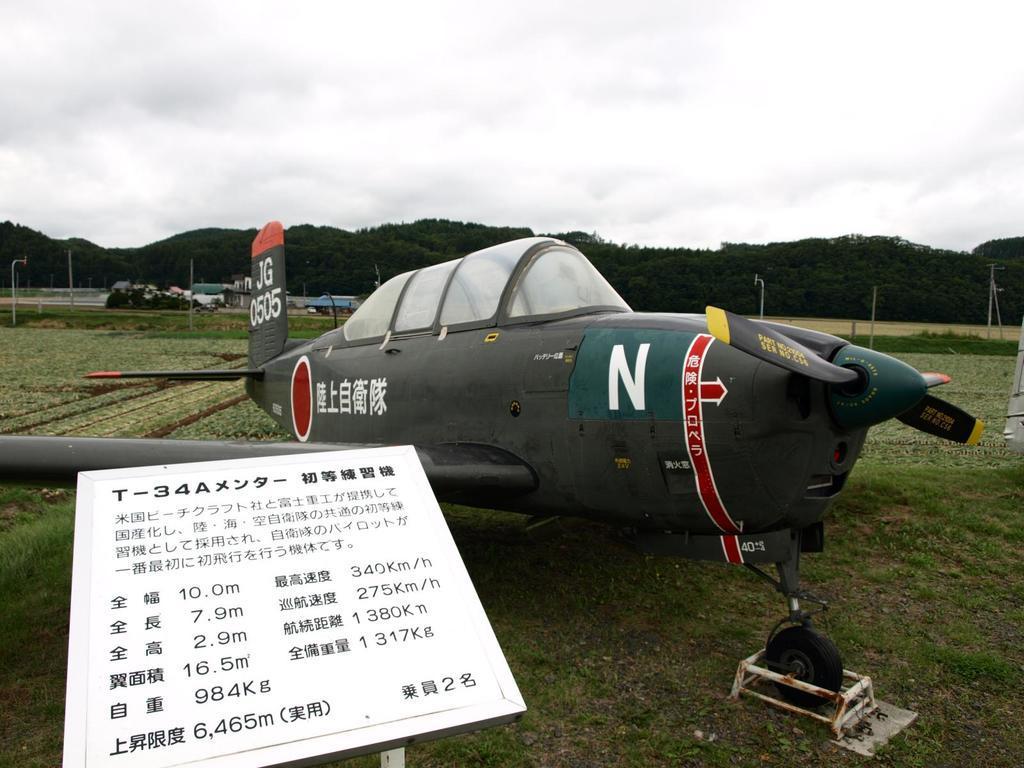Describe this image in one or two sentences. In this image we can see an aircraft and there are vehicles. At the bottom there is grass and we can see a board. In the background there are poles, hills and sky. 